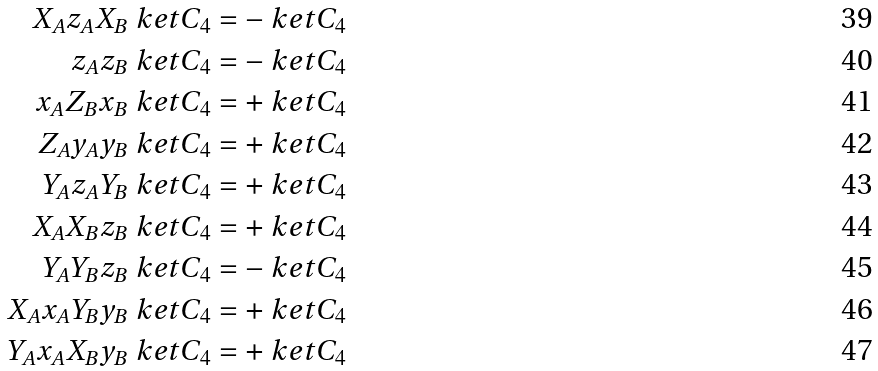<formula> <loc_0><loc_0><loc_500><loc_500>X _ { A } z _ { A } X _ { B } \ k e t { C _ { 4 } } & = - \ k e t { C _ { 4 } } \\ z _ { A } z _ { B } \ k e t { C _ { 4 } } & = - \ k e t { C _ { 4 } } \\ x _ { A } Z _ { B } x _ { B } \ k e t { C _ { 4 } } & = + \ k e t { C _ { 4 } } \\ Z _ { A } y _ { A } y _ { B } \ k e t { C _ { 4 } } & = + \ k e t { C _ { 4 } } \\ Y _ { A } z _ { A } Y _ { B } \ k e t { C _ { 4 } } & = + \ k e t { C _ { 4 } } \\ X _ { A } X _ { B } z _ { B } \ k e t { C _ { 4 } } & = + \ k e t { C _ { 4 } } \\ Y _ { A } Y _ { B } z _ { B } \ k e t { C _ { 4 } } & = - \ k e t { C _ { 4 } } \\ X _ { A } x _ { A } Y _ { B } y _ { B } \ k e t { C _ { 4 } } & = + \ k e t { C _ { 4 } } \\ Y _ { A } x _ { A } X _ { B } y _ { B } \ k e t { C _ { 4 } } & = + \ k e t { C _ { 4 } }</formula> 